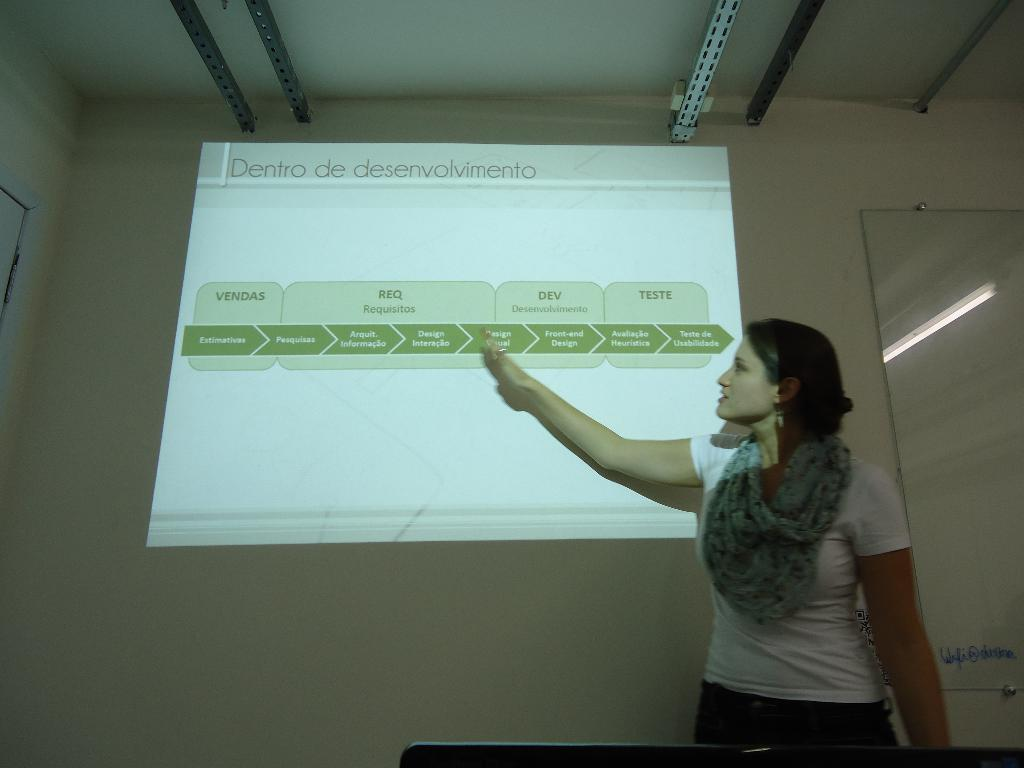Provide a one-sentence caption for the provided image. A woman pointing to a slide show titled "Dentro de desenvolvimento.". 